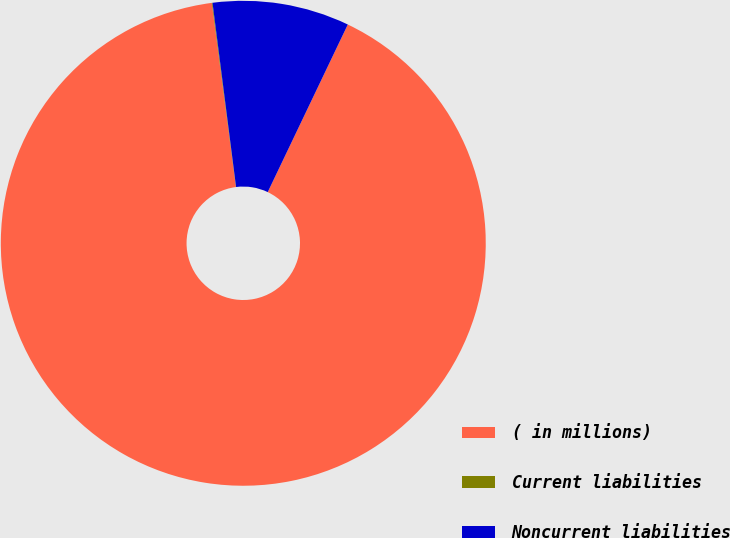Convert chart to OTSL. <chart><loc_0><loc_0><loc_500><loc_500><pie_chart><fcel>( in millions)<fcel>Current liabilities<fcel>Noncurrent liabilities<nl><fcel>90.83%<fcel>0.05%<fcel>9.12%<nl></chart> 